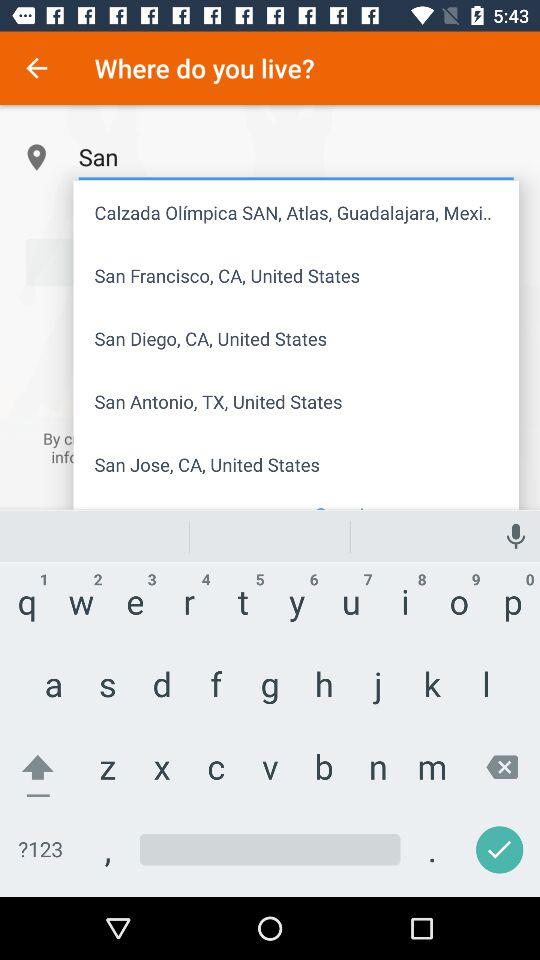What's the typed text? The typed text is "San". 